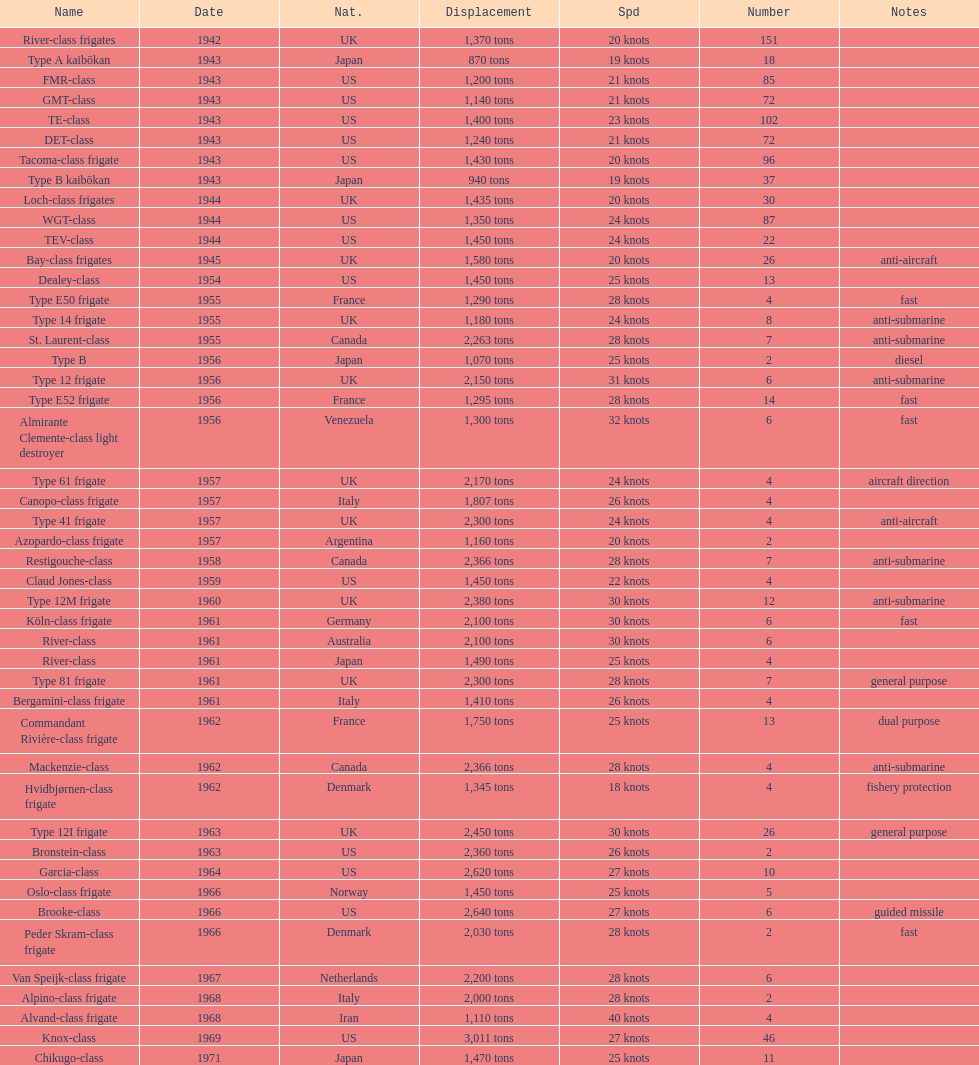Which of the boats listed is the fastest? Alvand-class frigate. 